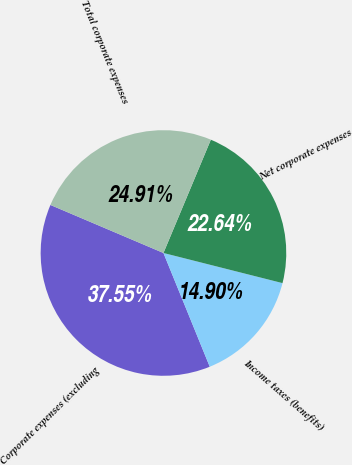Convert chart. <chart><loc_0><loc_0><loc_500><loc_500><pie_chart><fcel>Corporate expenses (excluding<fcel>Income taxes (benefits)<fcel>Net corporate expenses<fcel>Total corporate expenses<nl><fcel>37.55%<fcel>14.9%<fcel>22.64%<fcel>24.91%<nl></chart> 